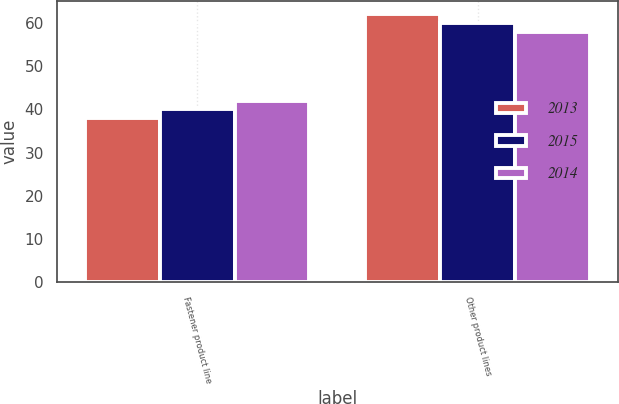Convert chart. <chart><loc_0><loc_0><loc_500><loc_500><stacked_bar_chart><ecel><fcel>Fastener product line<fcel>Other product lines<nl><fcel>2013<fcel>38<fcel>62<nl><fcel>2015<fcel>40<fcel>60<nl><fcel>2014<fcel>42<fcel>58<nl></chart> 